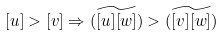<formula> <loc_0><loc_0><loc_500><loc_500>[ u ] > [ v ] \Rightarrow \widetilde { ( [ u ] [ w ] ) } > \widetilde { ( [ v ] [ w ] ) }</formula> 